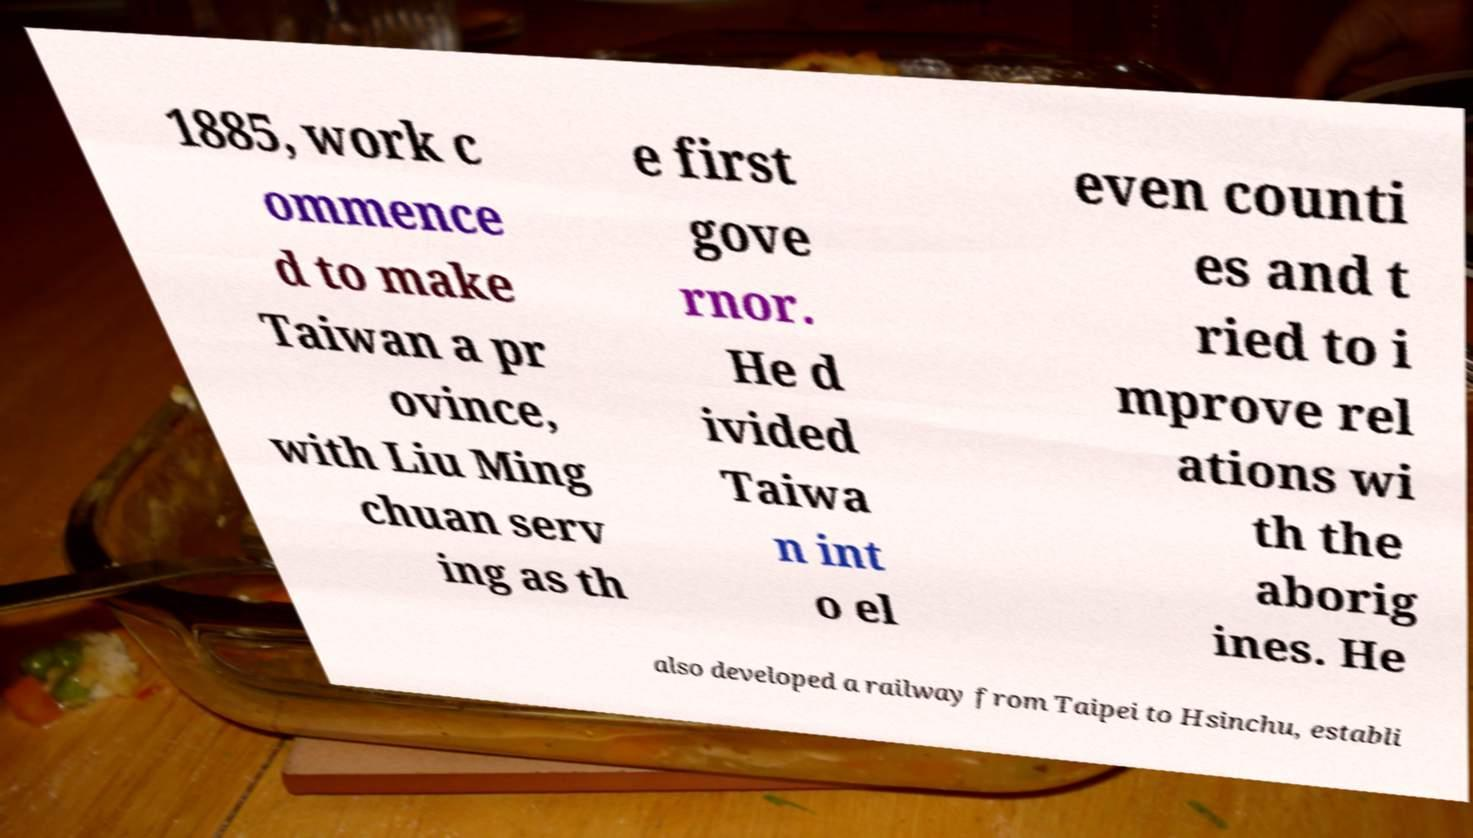For documentation purposes, I need the text within this image transcribed. Could you provide that? 1885, work c ommence d to make Taiwan a pr ovince, with Liu Ming chuan serv ing as th e first gove rnor. He d ivided Taiwa n int o el even counti es and t ried to i mprove rel ations wi th the aborig ines. He also developed a railway from Taipei to Hsinchu, establi 